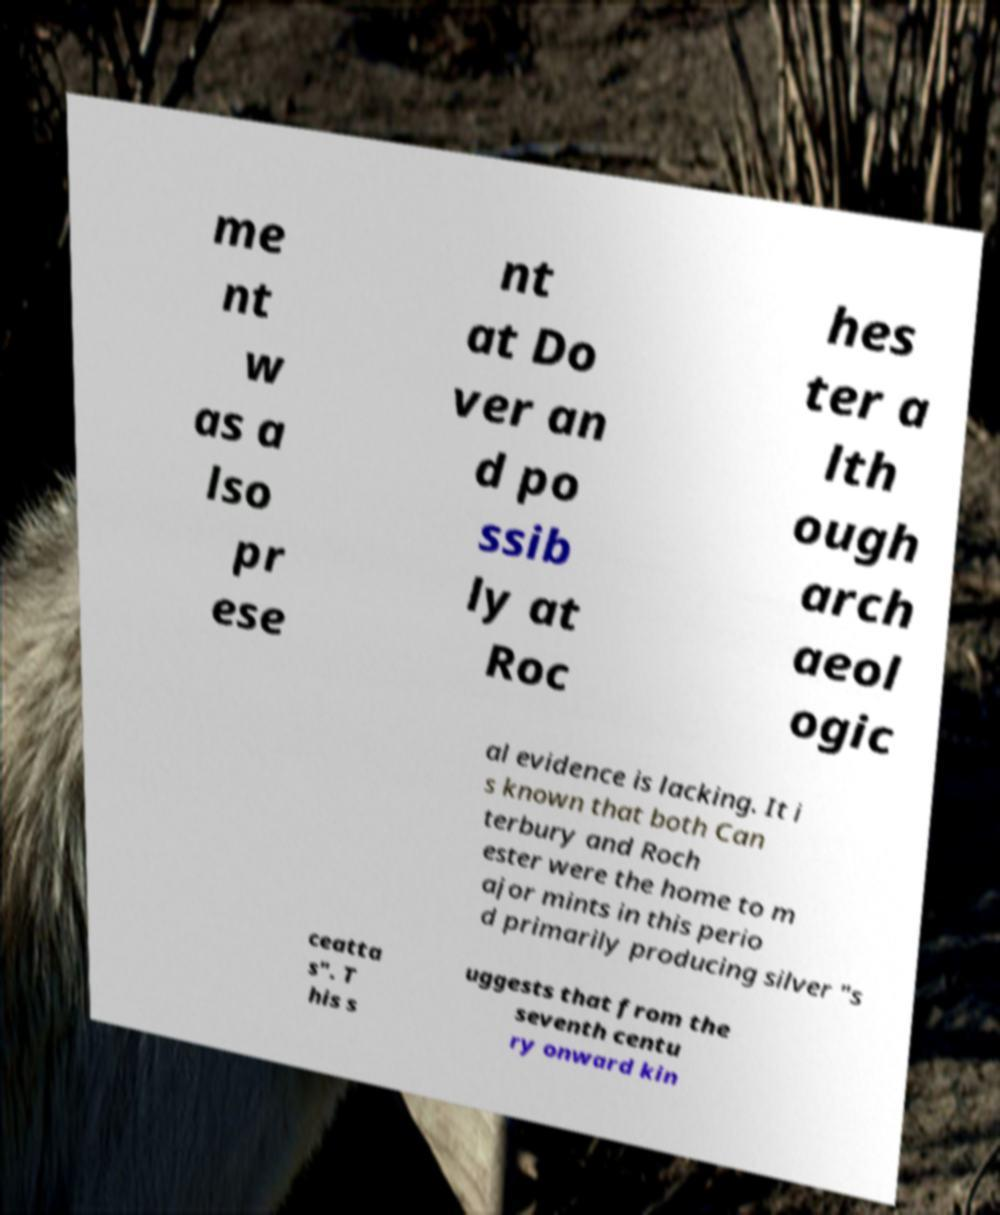Please identify and transcribe the text found in this image. me nt w as a lso pr ese nt at Do ver an d po ssib ly at Roc hes ter a lth ough arch aeol ogic al evidence is lacking. It i s known that both Can terbury and Roch ester were the home to m ajor mints in this perio d primarily producing silver "s ceatta s". T his s uggests that from the seventh centu ry onward kin 